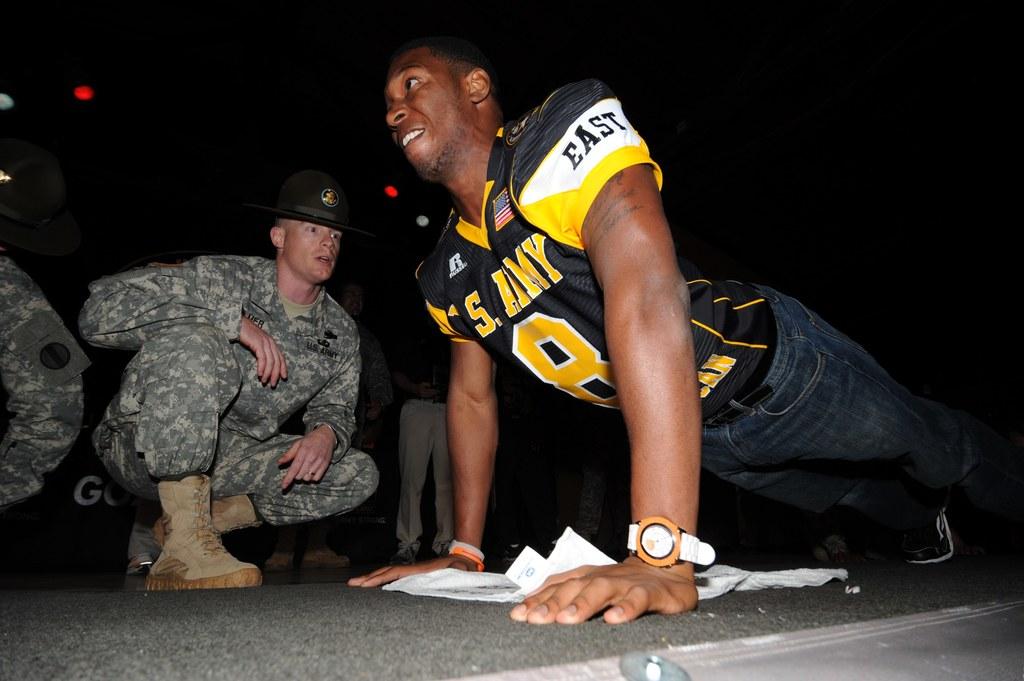What team is this drill sargent working out?
Ensure brevity in your answer.  Army. What is the players number?
Your answer should be compact. 8. 